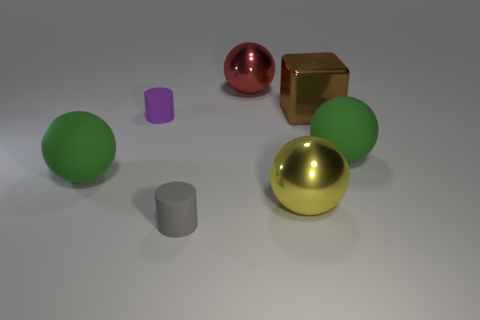Add 2 small yellow matte things. How many objects exist? 9 Subtract all gray spheres. Subtract all blue cylinders. How many spheres are left? 4 Subtract all blocks. How many objects are left? 6 Subtract 1 brown blocks. How many objects are left? 6 Subtract all small gray objects. Subtract all brown cubes. How many objects are left? 5 Add 6 big red things. How many big red things are left? 7 Add 7 big red things. How many big red things exist? 8 